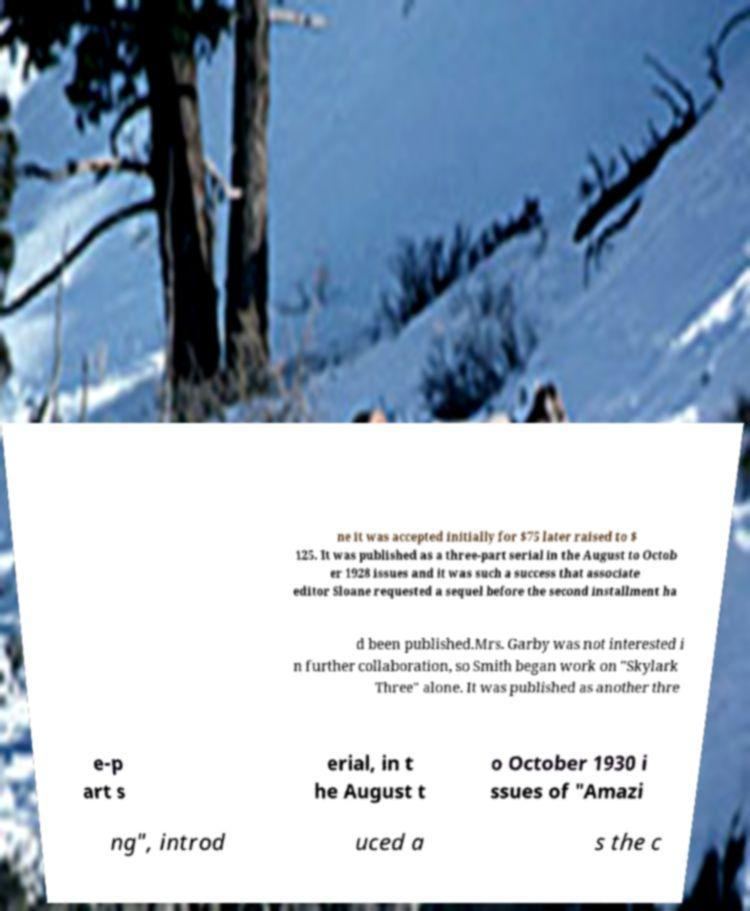Could you assist in decoding the text presented in this image and type it out clearly? ne it was accepted initially for $75 later raised to $ 125. It was published as a three-part serial in the August to Octob er 1928 issues and it was such a success that associate editor Sloane requested a sequel before the second installment ha d been published.Mrs. Garby was not interested i n further collaboration, so Smith began work on "Skylark Three" alone. It was published as another thre e-p art s erial, in t he August t o October 1930 i ssues of "Amazi ng", introd uced a s the c 